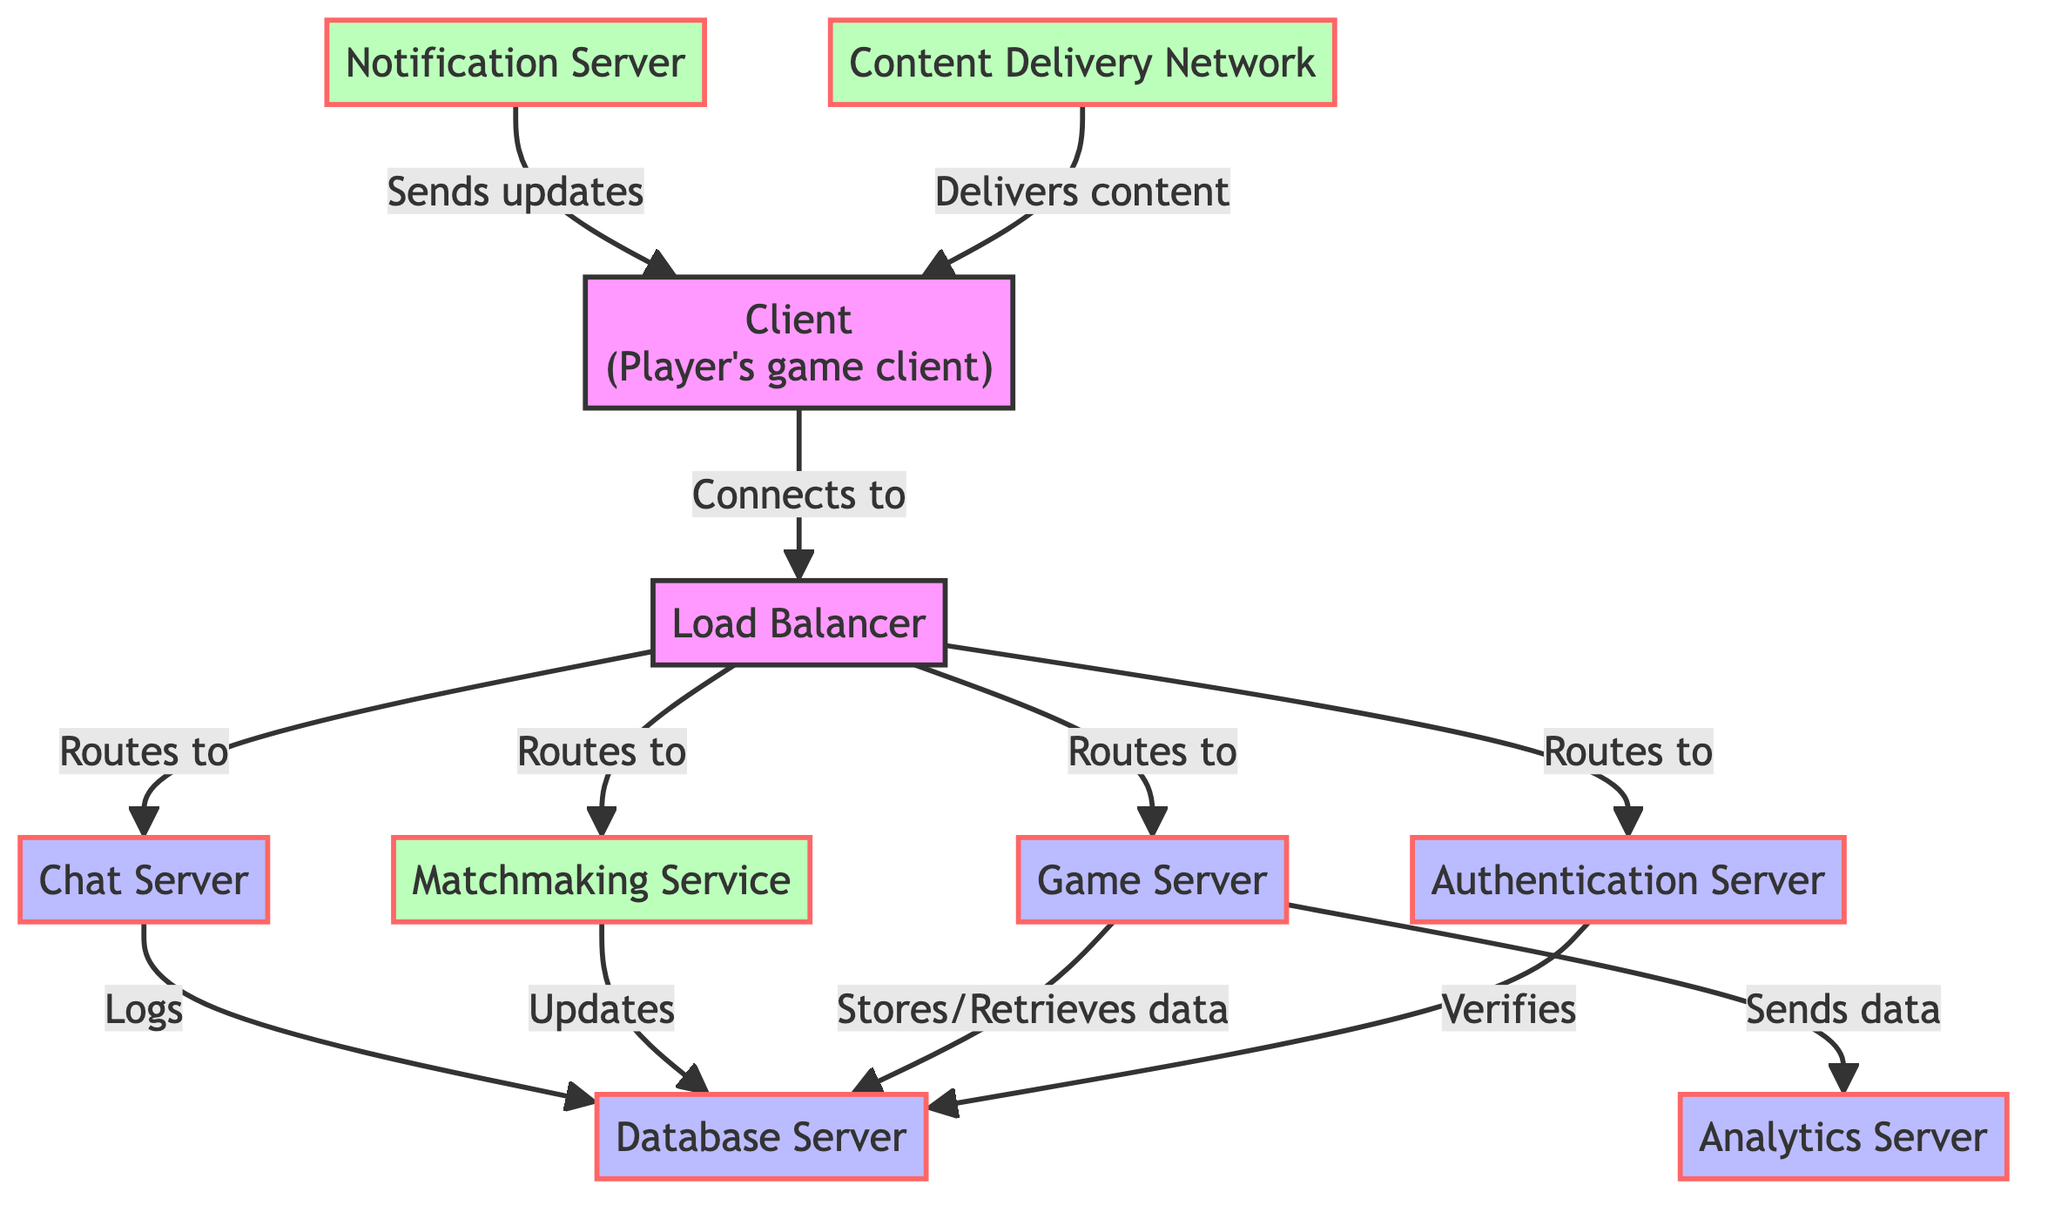What is the role of the Load Balancer? The Load Balancer distributes incoming traffic evenly across a group of servers to ensure no single server becomes overwhelmed. This helps to manage workloads effectively by directing players to available servers.
Answer: Distributes traffic Which server verifies player credentials? The Authentication Server is responsible for verifying player credentials and managing session tokens, ensuring players are authenticated before they can access the game.
Answer: Authentication Server How many servers are responsible for storing persistent game data? The Database Server is the only component explicitly mentioned for storing persistent game data like player progress and game state, indicating that only one database server serves this purpose in the architecture.
Answer: One What type of service handles in-game communication? The Chat Server manages in-game communication between players, facilitating discussions and coordination during the gameplay.
Answer: Chat Server What does the Analytics Server do? The Analytics Server collects and processes game-related data to provide insights that can help improve game performance and player experience, indicating its role in data analysis.
Answer: Collects data Which components does the Load Balancer route to? The Load Balancer routes to the Authentication Server, Game Server, Matchmaking Service, and Chat Server, showing its central role in managing player connections to various functionalities.
Answer: Four components How does the Game Server interact with the Database Server? The Game Server stores and retrieves data to and from the Database Server, indicating a bi-directional data flow between these two components to maintain game state and player progress.
Answer: Stores and retrieves What does the Content Delivery Network deliver? The Content Delivery Network (CDN) delivers game assets and updates to players, ensuring that they receive the necessary content for a smooth gaming experience.
Answer: Game assets Which server is responsible for sending updates to players? The Notification Server sends in-game notifications and updates to players, ensuring they are informed about important information while playing.
Answer: Notification Server 